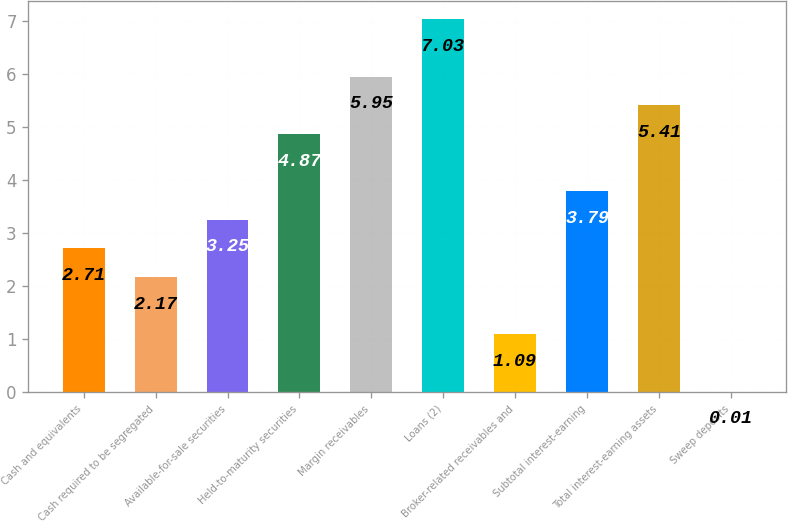Convert chart to OTSL. <chart><loc_0><loc_0><loc_500><loc_500><bar_chart><fcel>Cash and equivalents<fcel>Cash required to be segregated<fcel>Available-for-sale securities<fcel>Held-to-maturity securities<fcel>Margin receivables<fcel>Loans (2)<fcel>Broker-related receivables and<fcel>Subtotal interest-earning<fcel>Total interest-earning assets<fcel>Sweep deposits<nl><fcel>2.71<fcel>2.17<fcel>3.25<fcel>4.87<fcel>5.95<fcel>7.03<fcel>1.09<fcel>3.79<fcel>5.41<fcel>0.01<nl></chart> 